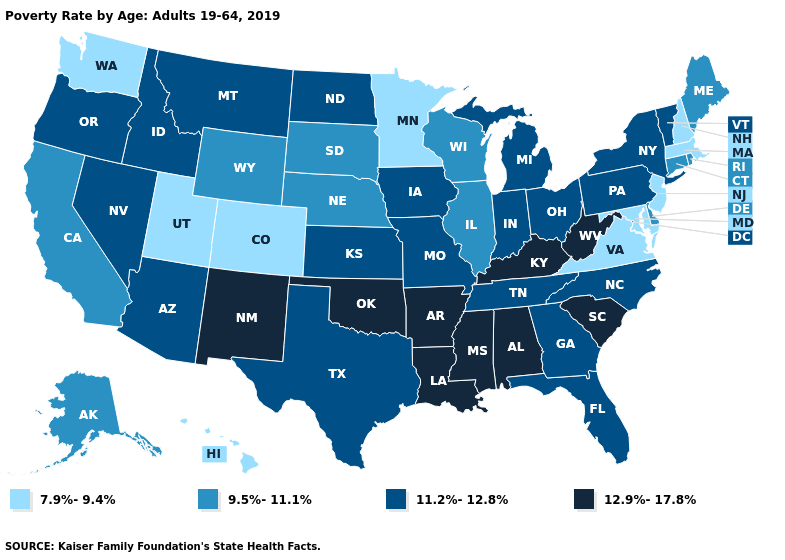Name the states that have a value in the range 9.5%-11.1%?
Write a very short answer. Alaska, California, Connecticut, Delaware, Illinois, Maine, Nebraska, Rhode Island, South Dakota, Wisconsin, Wyoming. Does South Carolina have the highest value in the USA?
Answer briefly. Yes. What is the lowest value in the West?
Give a very brief answer. 7.9%-9.4%. Among the states that border Oregon , does Idaho have the highest value?
Short answer required. Yes. What is the lowest value in states that border Pennsylvania?
Concise answer only. 7.9%-9.4%. Name the states that have a value in the range 12.9%-17.8%?
Short answer required. Alabama, Arkansas, Kentucky, Louisiana, Mississippi, New Mexico, Oklahoma, South Carolina, West Virginia. Does Florida have the highest value in the USA?
Short answer required. No. Among the states that border Maryland , which have the lowest value?
Short answer required. Virginia. Does Kansas have the lowest value in the USA?
Short answer required. No. Does the first symbol in the legend represent the smallest category?
Give a very brief answer. Yes. What is the lowest value in the USA?
Be succinct. 7.9%-9.4%. What is the highest value in the South ?
Give a very brief answer. 12.9%-17.8%. What is the value of Nevada?
Write a very short answer. 11.2%-12.8%. Among the states that border Minnesota , does South Dakota have the lowest value?
Concise answer only. Yes. Among the states that border Mississippi , which have the highest value?
Quick response, please. Alabama, Arkansas, Louisiana. 